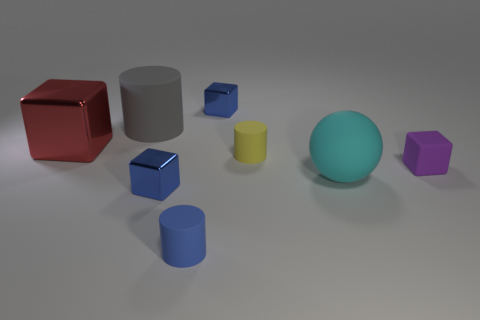Is there any other thing that is the same shape as the big cyan matte object?
Provide a short and direct response. No. There is a tiny rubber object that is left of the small yellow rubber cylinder; what shape is it?
Your response must be concise. Cylinder. What shape is the small shiny thing behind the big thing on the right side of the blue metallic thing that is in front of the tiny purple object?
Ensure brevity in your answer.  Cube. How many things are either big purple cylinders or balls?
Offer a very short reply. 1. Do the gray rubber object on the left side of the tiny purple matte block and the small metallic thing behind the large gray thing have the same shape?
Offer a terse response. No. What number of matte cylinders are both on the right side of the big gray thing and behind the blue rubber cylinder?
Offer a very short reply. 1. What number of other objects are there of the same size as the purple rubber cube?
Offer a very short reply. 4. There is a object that is both behind the small yellow matte cylinder and on the right side of the big gray thing; what is it made of?
Your answer should be compact. Metal. Do the rubber ball and the tiny metallic cube that is behind the small purple thing have the same color?
Keep it short and to the point. No. There is a purple rubber thing that is the same shape as the red object; what size is it?
Make the answer very short. Small. 